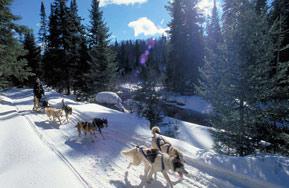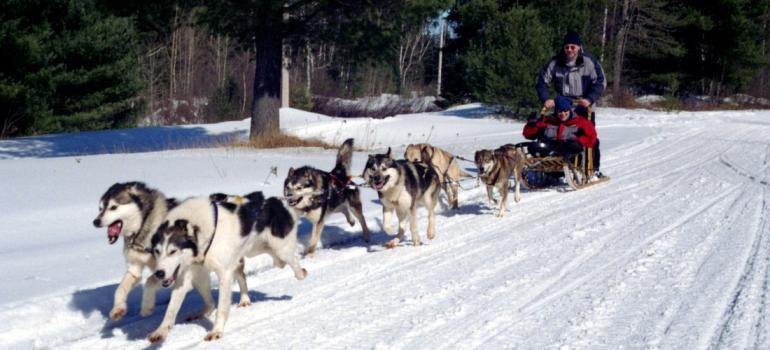The first image is the image on the left, the second image is the image on the right. Considering the images on both sides, is "One image features a sled dog team that is heading forward at an angle across a flattened snow path to the right." valid? Answer yes or no. Yes. 